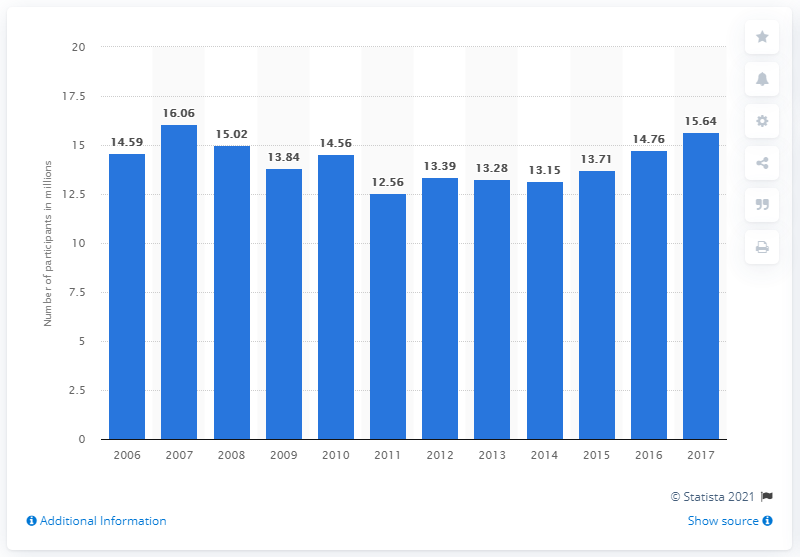Specify some key components in this picture. In 2017, the total number of participants in baseball was 15.64 million. 